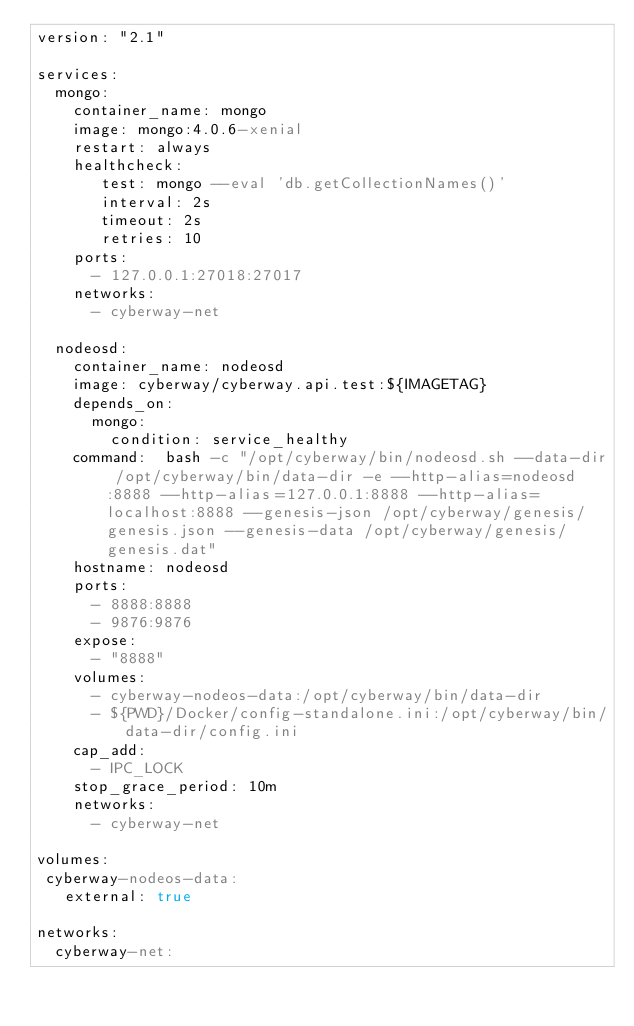Convert code to text. <code><loc_0><loc_0><loc_500><loc_500><_YAML_>version: "2.1"

services:
  mongo:
    container_name: mongo
    image: mongo:4.0.6-xenial
    restart: always
    healthcheck:
       test: mongo --eval 'db.getCollectionNames()'
       interval: 2s
       timeout: 2s
       retries: 10
    ports:
      - 127.0.0.1:27018:27017
    networks:
      - cyberway-net

  nodeosd:
    container_name: nodeosd
    image: cyberway/cyberway.api.test:${IMAGETAG}
    depends_on:
      mongo:
        condition: service_healthy
    command:  bash -c "/opt/cyberway/bin/nodeosd.sh --data-dir /opt/cyberway/bin/data-dir -e --http-alias=nodeosd:8888 --http-alias=127.0.0.1:8888 --http-alias=localhost:8888 --genesis-json /opt/cyberway/genesis/genesis.json --genesis-data /opt/cyberway/genesis/genesis.dat"
    hostname: nodeosd
    ports:
      - 8888:8888
      - 9876:9876
    expose:
      - "8888"
    volumes:
      - cyberway-nodeos-data:/opt/cyberway/bin/data-dir
      - ${PWD}/Docker/config-standalone.ini:/opt/cyberway/bin/data-dir/config.ini
    cap_add:
      - IPC_LOCK
    stop_grace_period: 10m
    networks:
      - cyberway-net

volumes:
 cyberway-nodeos-data:
   external: true

networks:
  cyberway-net:
</code> 